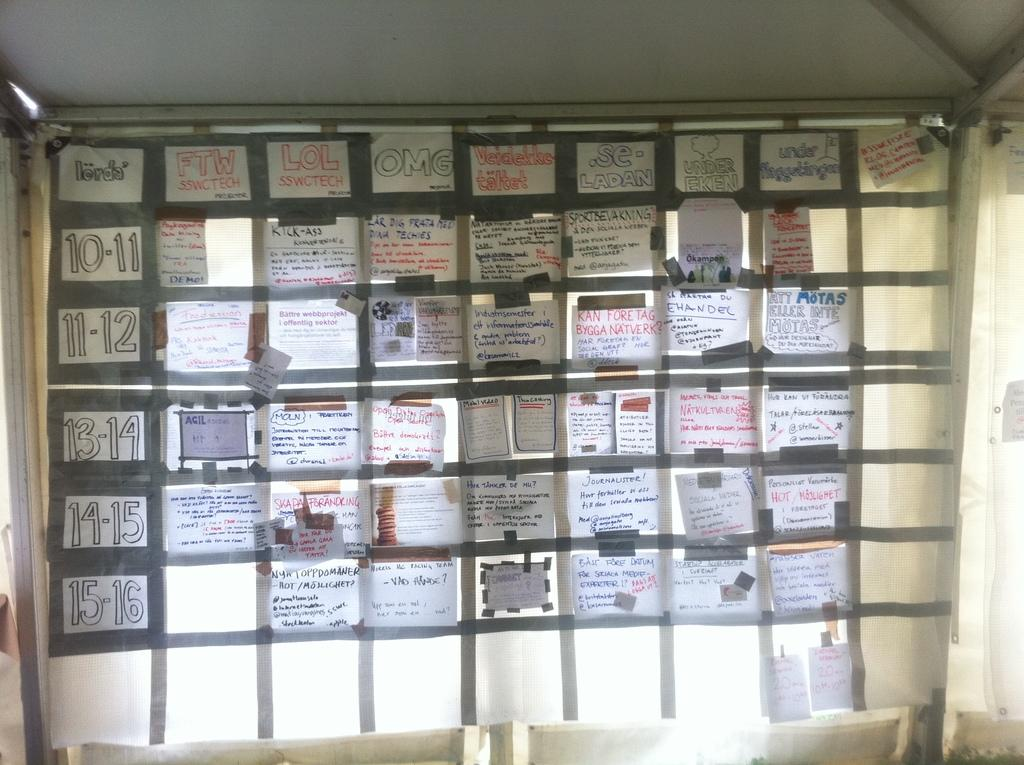What is present on the white cloth in the image? There are papers in the image, and they are pasted with tape. What is the color of the cloth that the papers are on? The white cloth is the color of the cloth that the papers are on. How are the iron poles connected to the white cloth? The white cloth is tied to iron poles. What type of lead can be seen connecting the papers in the image? There is no lead present in the image; the papers are pasted with tape. On which side of the iron poles are the papers located? The image does not specify a particular side of the iron poles where the papers are located. 